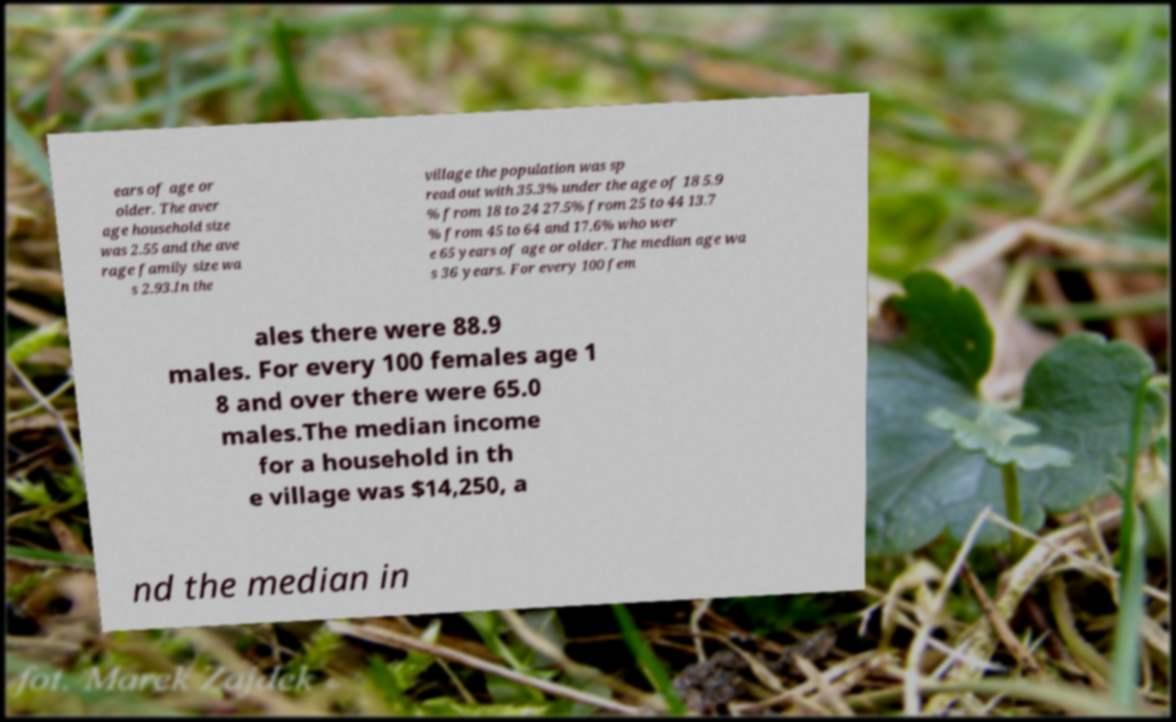Could you assist in decoding the text presented in this image and type it out clearly? ears of age or older. The aver age household size was 2.55 and the ave rage family size wa s 2.93.In the village the population was sp read out with 35.3% under the age of 18 5.9 % from 18 to 24 27.5% from 25 to 44 13.7 % from 45 to 64 and 17.6% who wer e 65 years of age or older. The median age wa s 36 years. For every 100 fem ales there were 88.9 males. For every 100 females age 1 8 and over there were 65.0 males.The median income for a household in th e village was $14,250, a nd the median in 